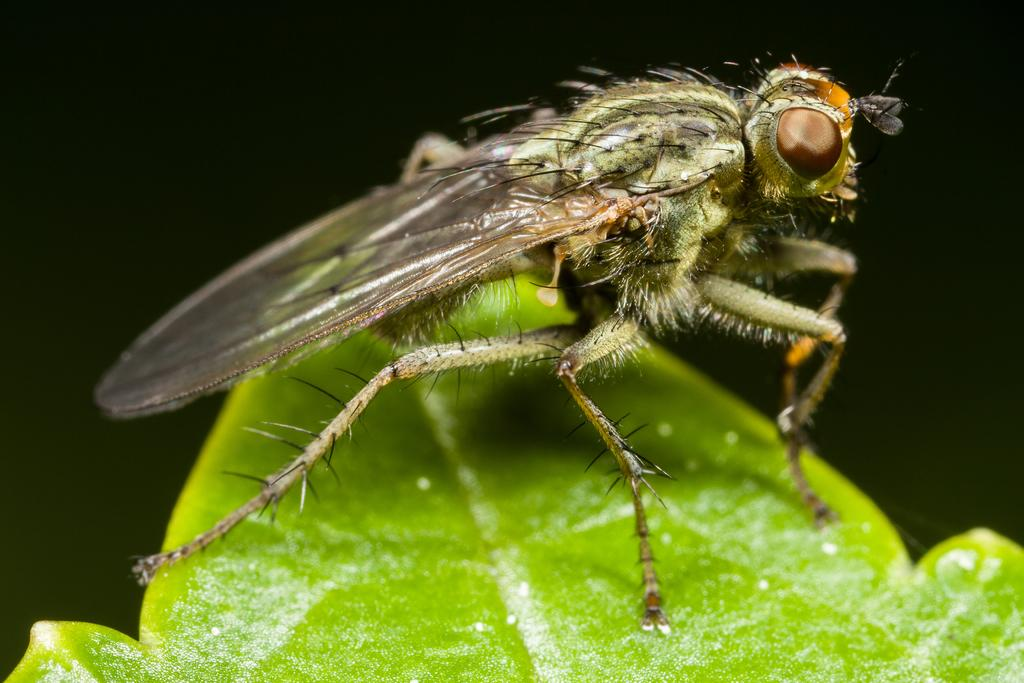What type of creature is in the image? There is an insect in the image. Can you describe the insect? The insect resembles a housefly. Where is the insect located in the image? The insect is on a green leaf. What is the color of the background in the image? The background of the image is black. What type of cable can be seen in the image? There is no cable present in the image; it features an insect on a green leaf with a black background. How many times does the insect sneeze in the image? Insects do not have the ability to sneeze, and there is no indication of sneezing in the image. 